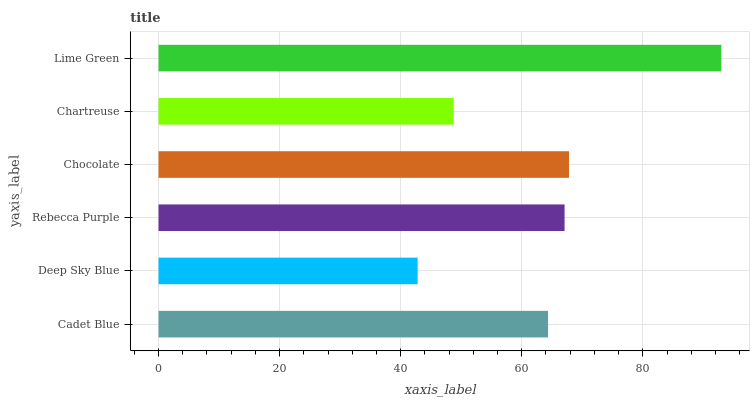Is Deep Sky Blue the minimum?
Answer yes or no. Yes. Is Lime Green the maximum?
Answer yes or no. Yes. Is Rebecca Purple the minimum?
Answer yes or no. No. Is Rebecca Purple the maximum?
Answer yes or no. No. Is Rebecca Purple greater than Deep Sky Blue?
Answer yes or no. Yes. Is Deep Sky Blue less than Rebecca Purple?
Answer yes or no. Yes. Is Deep Sky Blue greater than Rebecca Purple?
Answer yes or no. No. Is Rebecca Purple less than Deep Sky Blue?
Answer yes or no. No. Is Rebecca Purple the high median?
Answer yes or no. Yes. Is Cadet Blue the low median?
Answer yes or no. Yes. Is Cadet Blue the high median?
Answer yes or no. No. Is Lime Green the low median?
Answer yes or no. No. 